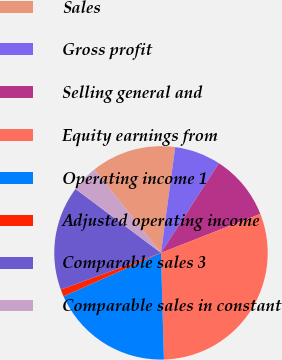Convert chart to OTSL. <chart><loc_0><loc_0><loc_500><loc_500><pie_chart><fcel>Sales<fcel>Gross profit<fcel>Selling general and<fcel>Equity earnings from<fcel>Operating income 1<fcel>Adjusted operating income<fcel>Comparable sales 3<fcel>Comparable sales in constant<nl><fcel>12.87%<fcel>6.99%<fcel>9.93%<fcel>30.51%<fcel>18.75%<fcel>1.1%<fcel>15.81%<fcel>4.04%<nl></chart> 